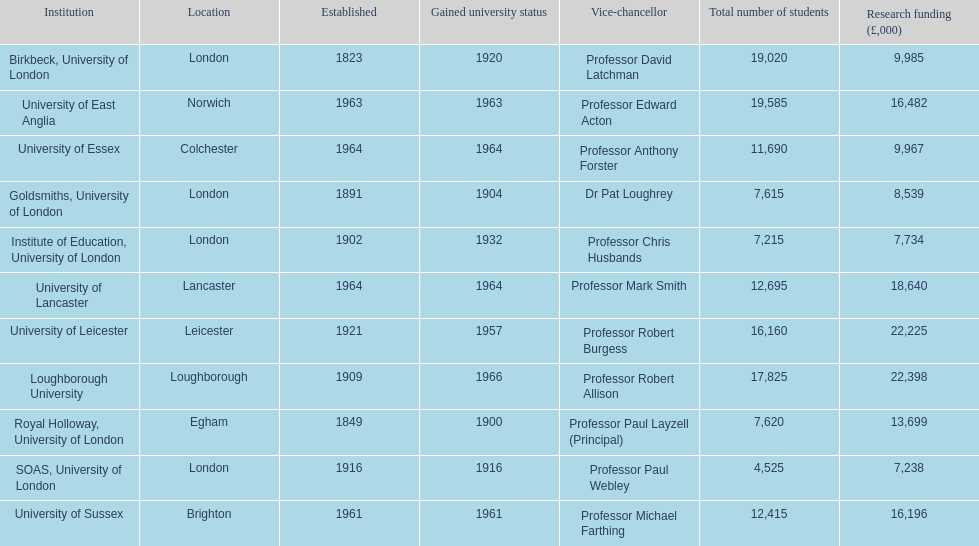What is the most recent institution to gain university status? Loughborough University. 